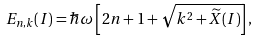Convert formula to latex. <formula><loc_0><loc_0><loc_500><loc_500>E _ { n , k } ( I ) = \hbar { \omega } \left [ 2 n + 1 + \sqrt { k ^ { 2 } + \widetilde { X } ( I ) } \right ] ,</formula> 